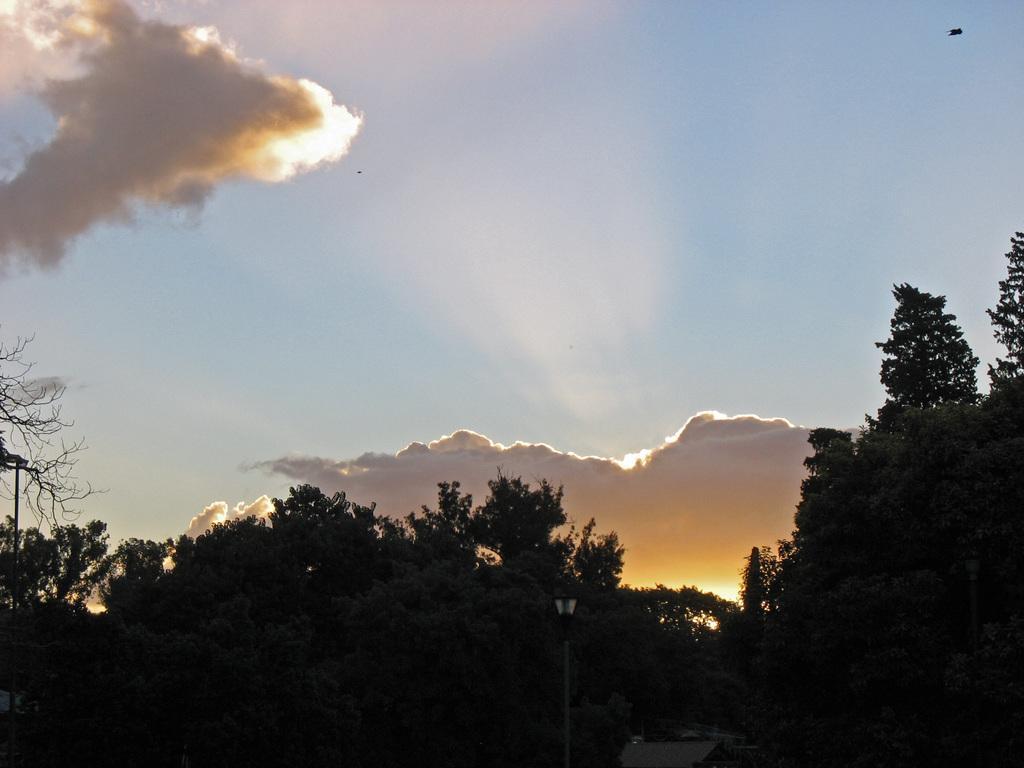Describe this image in one or two sentences. In this picture we can see a few trees from left to right. Sky is blue in color and cloudy. 